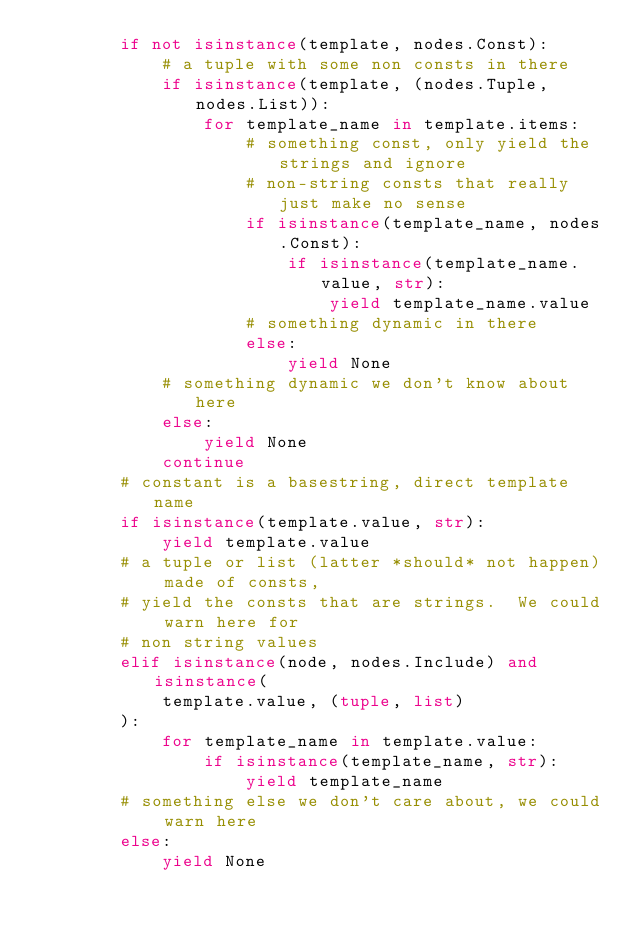<code> <loc_0><loc_0><loc_500><loc_500><_Python_>        if not isinstance(template, nodes.Const):
            # a tuple with some non consts in there
            if isinstance(template, (nodes.Tuple, nodes.List)):
                for template_name in template.items:
                    # something const, only yield the strings and ignore
                    # non-string consts that really just make no sense
                    if isinstance(template_name, nodes.Const):
                        if isinstance(template_name.value, str):
                            yield template_name.value
                    # something dynamic in there
                    else:
                        yield None
            # something dynamic we don't know about here
            else:
                yield None
            continue
        # constant is a basestring, direct template name
        if isinstance(template.value, str):
            yield template.value
        # a tuple or list (latter *should* not happen) made of consts,
        # yield the consts that are strings.  We could warn here for
        # non string values
        elif isinstance(node, nodes.Include) and isinstance(
            template.value, (tuple, list)
        ):
            for template_name in template.value:
                if isinstance(template_name, str):
                    yield template_name
        # something else we don't care about, we could warn here
        else:
            yield None
</code> 